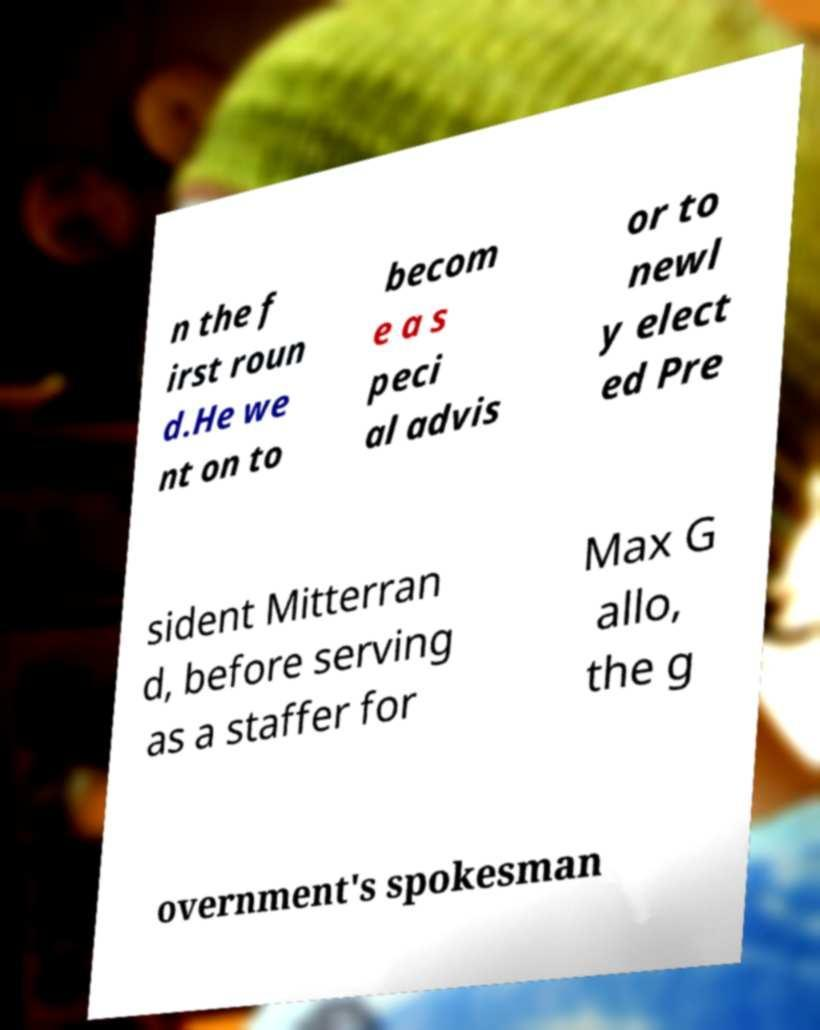Can you accurately transcribe the text from the provided image for me? n the f irst roun d.He we nt on to becom e a s peci al advis or to newl y elect ed Pre sident Mitterran d, before serving as a staffer for Max G allo, the g overnment's spokesman 